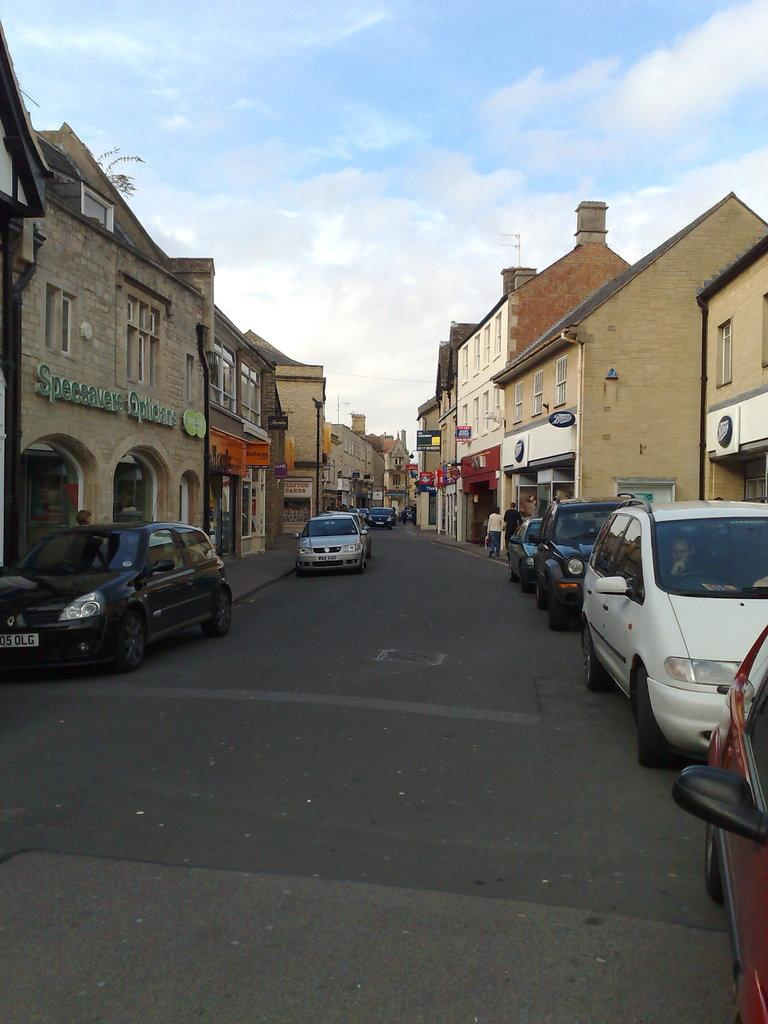What is the main feature in the center of the image? There is a road in the center of the image. What is happening on the road? Cars are present on the road. What can be seen in the background of the image? There are people and buildings in the background of the image, as well as the sky. How many books can be seen on the road in the image? There are no books present on the road in the image. 